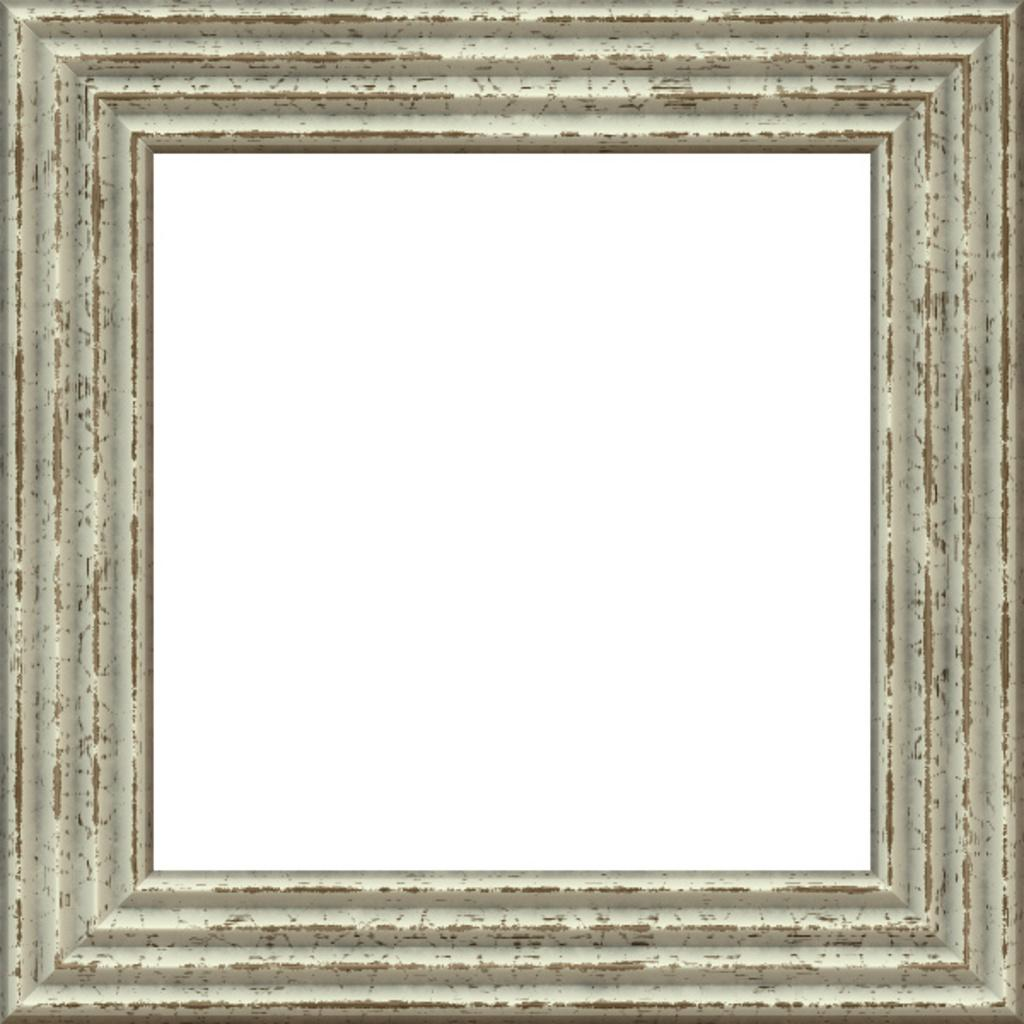What is the main object in the image? There is a frame in the image. What is the color of the background behind the frame? The background behind the frame is white. How many flowers are growing in the mouth of the frame? There are no flowers or mouth present in the image; it only features a frame with a white background. 